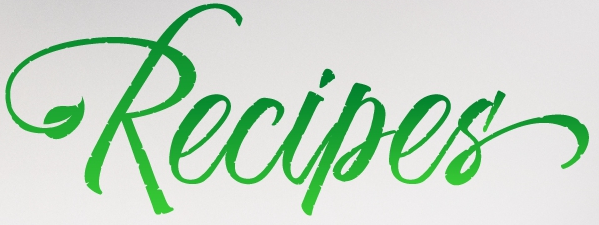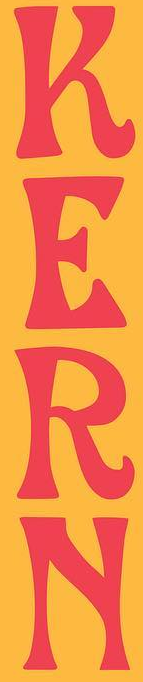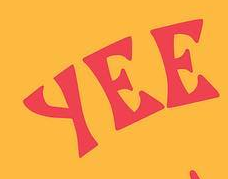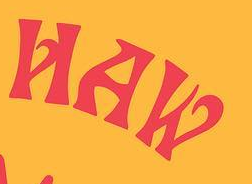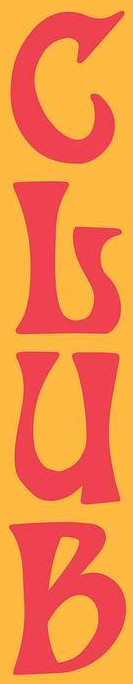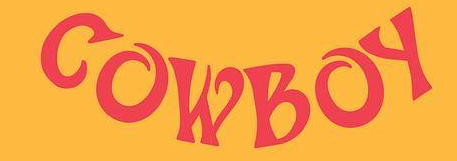What text appears in these images from left to right, separated by a semicolon? Recipes'; KERN; YEE; HAW; GLUB; COWBOY 